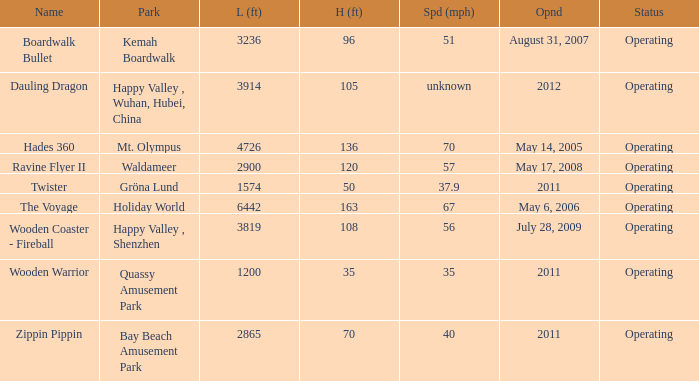How long is the rollar coaster on Kemah Boardwalk 3236.0. 